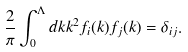Convert formula to latex. <formula><loc_0><loc_0><loc_500><loc_500>\frac { 2 } { \pi } \int ^ { \Lambda } _ { 0 } d k k ^ { 2 } f _ { i } ( k ) f _ { j } ( k ) = \delta _ { i j } .</formula> 